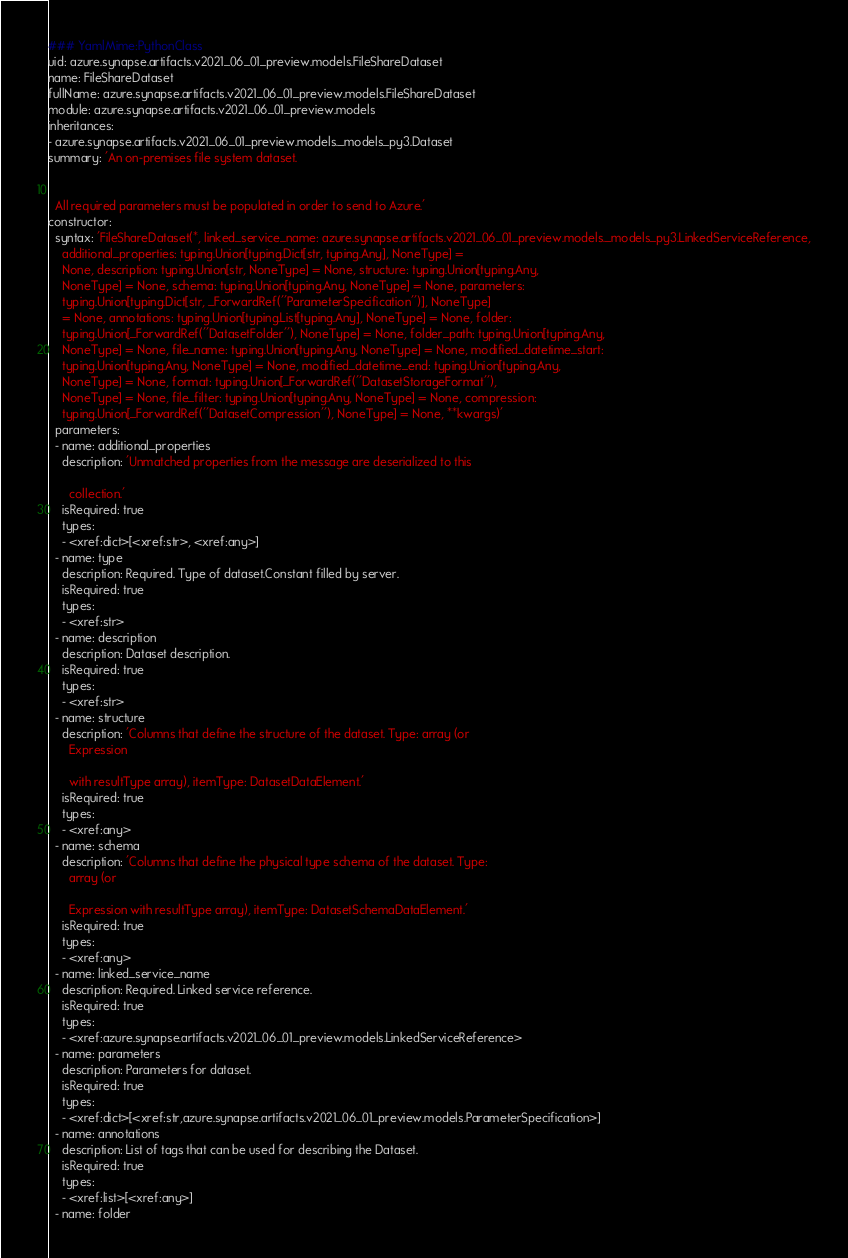<code> <loc_0><loc_0><loc_500><loc_500><_YAML_>### YamlMime:PythonClass
uid: azure.synapse.artifacts.v2021_06_01_preview.models.FileShareDataset
name: FileShareDataset
fullName: azure.synapse.artifacts.v2021_06_01_preview.models.FileShareDataset
module: azure.synapse.artifacts.v2021_06_01_preview.models
inheritances:
- azure.synapse.artifacts.v2021_06_01_preview.models._models_py3.Dataset
summary: 'An on-premises file system dataset.


  All required parameters must be populated in order to send to Azure.'
constructor:
  syntax: 'FileShareDataset(*, linked_service_name: azure.synapse.artifacts.v2021_06_01_preview.models._models_py3.LinkedServiceReference,
    additional_properties: typing.Union[typing.Dict[str, typing.Any], NoneType] =
    None, description: typing.Union[str, NoneType] = None, structure: typing.Union[typing.Any,
    NoneType] = None, schema: typing.Union[typing.Any, NoneType] = None, parameters:
    typing.Union[typing.Dict[str, _ForwardRef(''ParameterSpecification'')], NoneType]
    = None, annotations: typing.Union[typing.List[typing.Any], NoneType] = None, folder:
    typing.Union[_ForwardRef(''DatasetFolder''), NoneType] = None, folder_path: typing.Union[typing.Any,
    NoneType] = None, file_name: typing.Union[typing.Any, NoneType] = None, modified_datetime_start:
    typing.Union[typing.Any, NoneType] = None, modified_datetime_end: typing.Union[typing.Any,
    NoneType] = None, format: typing.Union[_ForwardRef(''DatasetStorageFormat''),
    NoneType] = None, file_filter: typing.Union[typing.Any, NoneType] = None, compression:
    typing.Union[_ForwardRef(''DatasetCompression''), NoneType] = None, **kwargs)'
  parameters:
  - name: additional_properties
    description: 'Unmatched properties from the message are deserialized to this

      collection.'
    isRequired: true
    types:
    - <xref:dict>[<xref:str>, <xref:any>]
  - name: type
    description: Required. Type of dataset.Constant filled by server.
    isRequired: true
    types:
    - <xref:str>
  - name: description
    description: Dataset description.
    isRequired: true
    types:
    - <xref:str>
  - name: structure
    description: 'Columns that define the structure of the dataset. Type: array (or
      Expression

      with resultType array), itemType: DatasetDataElement.'
    isRequired: true
    types:
    - <xref:any>
  - name: schema
    description: 'Columns that define the physical type schema of the dataset. Type:
      array (or

      Expression with resultType array), itemType: DatasetSchemaDataElement.'
    isRequired: true
    types:
    - <xref:any>
  - name: linked_service_name
    description: Required. Linked service reference.
    isRequired: true
    types:
    - <xref:azure.synapse.artifacts.v2021_06_01_preview.models.LinkedServiceReference>
  - name: parameters
    description: Parameters for dataset.
    isRequired: true
    types:
    - <xref:dict>[<xref:str,azure.synapse.artifacts.v2021_06_01_preview.models.ParameterSpecification>]
  - name: annotations
    description: List of tags that can be used for describing the Dataset.
    isRequired: true
    types:
    - <xref:list>[<xref:any>]
  - name: folder</code> 